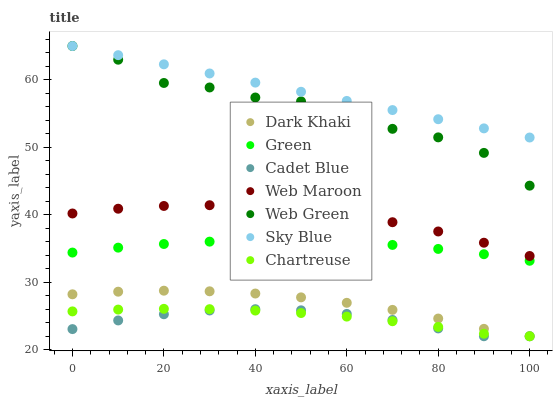Does Cadet Blue have the minimum area under the curve?
Answer yes or no. Yes. Does Sky Blue have the maximum area under the curve?
Answer yes or no. Yes. Does Web Maroon have the minimum area under the curve?
Answer yes or no. No. Does Web Maroon have the maximum area under the curve?
Answer yes or no. No. Is Sky Blue the smoothest?
Answer yes or no. Yes. Is Web Green the roughest?
Answer yes or no. Yes. Is Web Maroon the smoothest?
Answer yes or no. No. Is Web Maroon the roughest?
Answer yes or no. No. Does Cadet Blue have the lowest value?
Answer yes or no. Yes. Does Web Maroon have the lowest value?
Answer yes or no. No. Does Sky Blue have the highest value?
Answer yes or no. Yes. Does Web Maroon have the highest value?
Answer yes or no. No. Is Green less than Web Green?
Answer yes or no. Yes. Is Green greater than Dark Khaki?
Answer yes or no. Yes. Does Cadet Blue intersect Chartreuse?
Answer yes or no. Yes. Is Cadet Blue less than Chartreuse?
Answer yes or no. No. Is Cadet Blue greater than Chartreuse?
Answer yes or no. No. Does Green intersect Web Green?
Answer yes or no. No. 